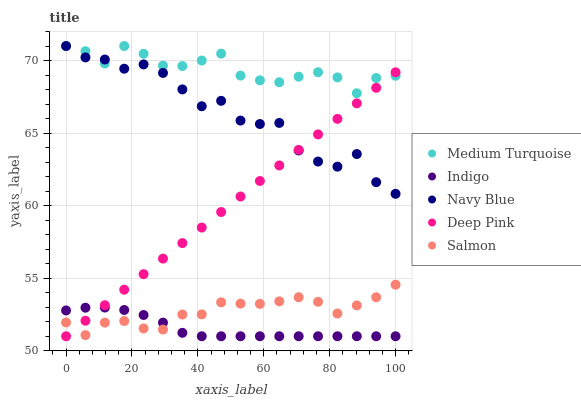Does Indigo have the minimum area under the curve?
Answer yes or no. Yes. Does Medium Turquoise have the maximum area under the curve?
Answer yes or no. Yes. Does Deep Pink have the minimum area under the curve?
Answer yes or no. No. Does Deep Pink have the maximum area under the curve?
Answer yes or no. No. Is Deep Pink the smoothest?
Answer yes or no. Yes. Is Navy Blue the roughest?
Answer yes or no. Yes. Is Indigo the smoothest?
Answer yes or no. No. Is Indigo the roughest?
Answer yes or no. No. Does Deep Pink have the lowest value?
Answer yes or no. Yes. Does Medium Turquoise have the lowest value?
Answer yes or no. No. Does Medium Turquoise have the highest value?
Answer yes or no. Yes. Does Deep Pink have the highest value?
Answer yes or no. No. Is Salmon less than Navy Blue?
Answer yes or no. Yes. Is Medium Turquoise greater than Indigo?
Answer yes or no. Yes. Does Indigo intersect Deep Pink?
Answer yes or no. Yes. Is Indigo less than Deep Pink?
Answer yes or no. No. Is Indigo greater than Deep Pink?
Answer yes or no. No. Does Salmon intersect Navy Blue?
Answer yes or no. No. 